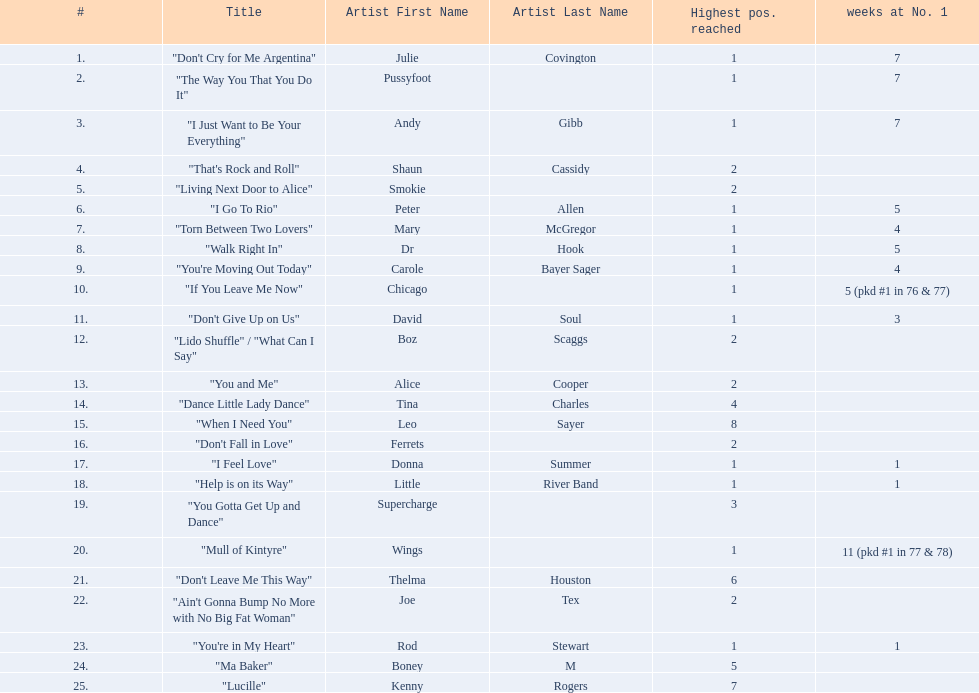Which artists were included in the top 25 singles for 1977 in australia? Julie Covington, Pussyfoot, Andy Gibb, Shaun Cassidy, Smokie, Peter Allen, Mary McGregor, Dr Hook, Carole Bayer Sager, Chicago, David Soul, Boz Scaggs, Alice Cooper, Tina Charles, Leo Sayer, Ferrets, Donna Summer, Little River Band, Supercharge, Wings, Thelma Houston, Joe Tex, Rod Stewart, Boney M, Kenny Rogers. And for how many weeks did they chart at number 1? 7, 7, 7, , , 5, 4, 5, 4, 5 (pkd #1 in 76 & 77), 3, , , , , , 1, 1, , 11 (pkd #1 in 77 & 78), , , 1, , . Which artist was in the number 1 spot for most time? Wings. 